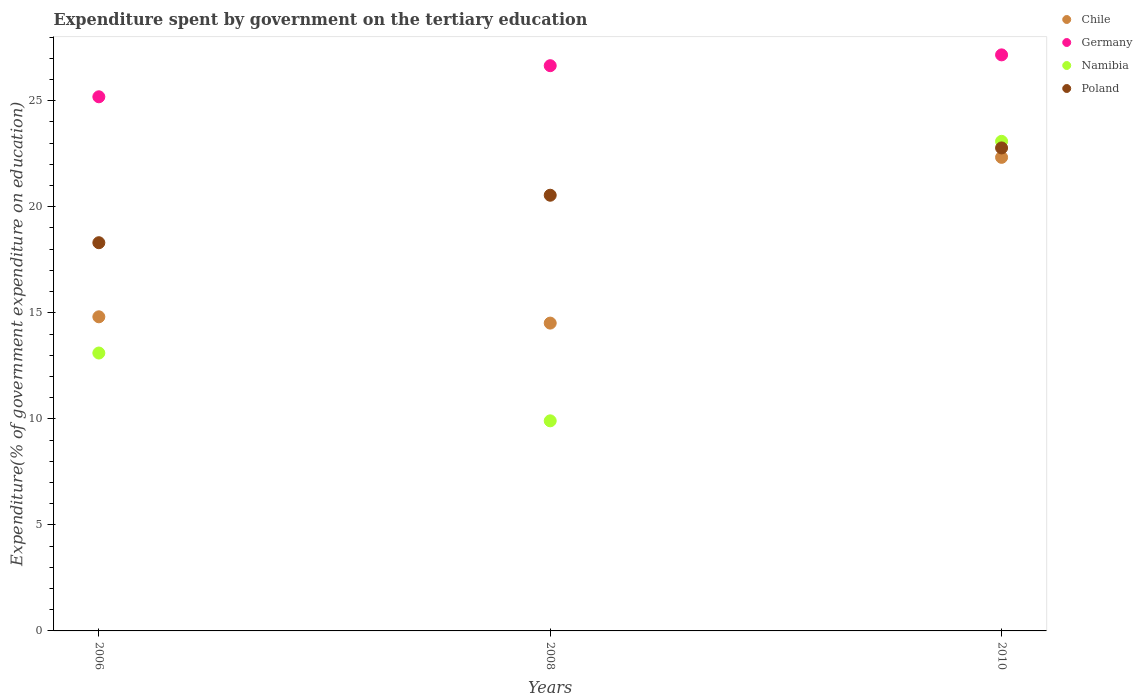Is the number of dotlines equal to the number of legend labels?
Keep it short and to the point. Yes. What is the expenditure spent by government on the tertiary education in Namibia in 2008?
Make the answer very short. 9.91. Across all years, what is the maximum expenditure spent by government on the tertiary education in Namibia?
Ensure brevity in your answer.  23.09. Across all years, what is the minimum expenditure spent by government on the tertiary education in Poland?
Provide a short and direct response. 18.31. In which year was the expenditure spent by government on the tertiary education in Germany minimum?
Make the answer very short. 2006. What is the total expenditure spent by government on the tertiary education in Poland in the graph?
Make the answer very short. 61.62. What is the difference between the expenditure spent by government on the tertiary education in Poland in 2006 and that in 2008?
Offer a very short reply. -2.24. What is the difference between the expenditure spent by government on the tertiary education in Chile in 2006 and the expenditure spent by government on the tertiary education in Germany in 2010?
Provide a short and direct response. -12.35. What is the average expenditure spent by government on the tertiary education in Poland per year?
Ensure brevity in your answer.  20.54. In the year 2008, what is the difference between the expenditure spent by government on the tertiary education in Namibia and expenditure spent by government on the tertiary education in Poland?
Offer a terse response. -10.64. What is the ratio of the expenditure spent by government on the tertiary education in Germany in 2006 to that in 2010?
Make the answer very short. 0.93. Is the expenditure spent by government on the tertiary education in Chile in 2006 less than that in 2010?
Provide a succinct answer. Yes. What is the difference between the highest and the second highest expenditure spent by government on the tertiary education in Germany?
Keep it short and to the point. 0.51. What is the difference between the highest and the lowest expenditure spent by government on the tertiary education in Germany?
Make the answer very short. 1.98. Is it the case that in every year, the sum of the expenditure spent by government on the tertiary education in Poland and expenditure spent by government on the tertiary education in Chile  is greater than the expenditure spent by government on the tertiary education in Namibia?
Keep it short and to the point. Yes. Does the expenditure spent by government on the tertiary education in Germany monotonically increase over the years?
Offer a terse response. Yes. Is the expenditure spent by government on the tertiary education in Namibia strictly greater than the expenditure spent by government on the tertiary education in Chile over the years?
Offer a very short reply. No. How many years are there in the graph?
Offer a terse response. 3. Are the values on the major ticks of Y-axis written in scientific E-notation?
Give a very brief answer. No. Does the graph contain any zero values?
Provide a short and direct response. No. Does the graph contain grids?
Provide a succinct answer. No. Where does the legend appear in the graph?
Give a very brief answer. Top right. How many legend labels are there?
Ensure brevity in your answer.  4. What is the title of the graph?
Ensure brevity in your answer.  Expenditure spent by government on the tertiary education. What is the label or title of the X-axis?
Provide a short and direct response. Years. What is the label or title of the Y-axis?
Provide a short and direct response. Expenditure(% of government expenditure on education). What is the Expenditure(% of government expenditure on education) in Chile in 2006?
Keep it short and to the point. 14.81. What is the Expenditure(% of government expenditure on education) of Germany in 2006?
Give a very brief answer. 25.19. What is the Expenditure(% of government expenditure on education) of Namibia in 2006?
Give a very brief answer. 13.1. What is the Expenditure(% of government expenditure on education) in Poland in 2006?
Keep it short and to the point. 18.31. What is the Expenditure(% of government expenditure on education) of Chile in 2008?
Ensure brevity in your answer.  14.51. What is the Expenditure(% of government expenditure on education) in Germany in 2008?
Offer a terse response. 26.65. What is the Expenditure(% of government expenditure on education) of Namibia in 2008?
Ensure brevity in your answer.  9.91. What is the Expenditure(% of government expenditure on education) in Poland in 2008?
Your response must be concise. 20.54. What is the Expenditure(% of government expenditure on education) in Chile in 2010?
Provide a succinct answer. 22.33. What is the Expenditure(% of government expenditure on education) of Germany in 2010?
Offer a very short reply. 27.16. What is the Expenditure(% of government expenditure on education) in Namibia in 2010?
Offer a terse response. 23.09. What is the Expenditure(% of government expenditure on education) in Poland in 2010?
Keep it short and to the point. 22.77. Across all years, what is the maximum Expenditure(% of government expenditure on education) of Chile?
Provide a short and direct response. 22.33. Across all years, what is the maximum Expenditure(% of government expenditure on education) of Germany?
Provide a short and direct response. 27.16. Across all years, what is the maximum Expenditure(% of government expenditure on education) in Namibia?
Your response must be concise. 23.09. Across all years, what is the maximum Expenditure(% of government expenditure on education) in Poland?
Make the answer very short. 22.77. Across all years, what is the minimum Expenditure(% of government expenditure on education) in Chile?
Give a very brief answer. 14.51. Across all years, what is the minimum Expenditure(% of government expenditure on education) of Germany?
Provide a succinct answer. 25.19. Across all years, what is the minimum Expenditure(% of government expenditure on education) in Namibia?
Your answer should be compact. 9.91. Across all years, what is the minimum Expenditure(% of government expenditure on education) in Poland?
Offer a very short reply. 18.31. What is the total Expenditure(% of government expenditure on education) of Chile in the graph?
Offer a very short reply. 51.66. What is the total Expenditure(% of government expenditure on education) of Germany in the graph?
Ensure brevity in your answer.  79. What is the total Expenditure(% of government expenditure on education) in Namibia in the graph?
Offer a terse response. 46.1. What is the total Expenditure(% of government expenditure on education) in Poland in the graph?
Your answer should be very brief. 61.62. What is the difference between the Expenditure(% of government expenditure on education) of Chile in 2006 and that in 2008?
Your response must be concise. 0.3. What is the difference between the Expenditure(% of government expenditure on education) of Germany in 2006 and that in 2008?
Ensure brevity in your answer.  -1.47. What is the difference between the Expenditure(% of government expenditure on education) in Namibia in 2006 and that in 2008?
Ensure brevity in your answer.  3.2. What is the difference between the Expenditure(% of government expenditure on education) of Poland in 2006 and that in 2008?
Offer a very short reply. -2.24. What is the difference between the Expenditure(% of government expenditure on education) in Chile in 2006 and that in 2010?
Offer a very short reply. -7.52. What is the difference between the Expenditure(% of government expenditure on education) in Germany in 2006 and that in 2010?
Keep it short and to the point. -1.98. What is the difference between the Expenditure(% of government expenditure on education) in Namibia in 2006 and that in 2010?
Provide a succinct answer. -9.98. What is the difference between the Expenditure(% of government expenditure on education) of Poland in 2006 and that in 2010?
Give a very brief answer. -4.47. What is the difference between the Expenditure(% of government expenditure on education) in Chile in 2008 and that in 2010?
Offer a very short reply. -7.82. What is the difference between the Expenditure(% of government expenditure on education) of Germany in 2008 and that in 2010?
Give a very brief answer. -0.51. What is the difference between the Expenditure(% of government expenditure on education) of Namibia in 2008 and that in 2010?
Make the answer very short. -13.18. What is the difference between the Expenditure(% of government expenditure on education) in Poland in 2008 and that in 2010?
Offer a very short reply. -2.23. What is the difference between the Expenditure(% of government expenditure on education) of Chile in 2006 and the Expenditure(% of government expenditure on education) of Germany in 2008?
Offer a terse response. -11.84. What is the difference between the Expenditure(% of government expenditure on education) of Chile in 2006 and the Expenditure(% of government expenditure on education) of Namibia in 2008?
Keep it short and to the point. 4.91. What is the difference between the Expenditure(% of government expenditure on education) of Chile in 2006 and the Expenditure(% of government expenditure on education) of Poland in 2008?
Ensure brevity in your answer.  -5.73. What is the difference between the Expenditure(% of government expenditure on education) in Germany in 2006 and the Expenditure(% of government expenditure on education) in Namibia in 2008?
Give a very brief answer. 15.28. What is the difference between the Expenditure(% of government expenditure on education) of Germany in 2006 and the Expenditure(% of government expenditure on education) of Poland in 2008?
Ensure brevity in your answer.  4.64. What is the difference between the Expenditure(% of government expenditure on education) of Namibia in 2006 and the Expenditure(% of government expenditure on education) of Poland in 2008?
Give a very brief answer. -7.44. What is the difference between the Expenditure(% of government expenditure on education) of Chile in 2006 and the Expenditure(% of government expenditure on education) of Germany in 2010?
Make the answer very short. -12.35. What is the difference between the Expenditure(% of government expenditure on education) of Chile in 2006 and the Expenditure(% of government expenditure on education) of Namibia in 2010?
Offer a terse response. -8.27. What is the difference between the Expenditure(% of government expenditure on education) in Chile in 2006 and the Expenditure(% of government expenditure on education) in Poland in 2010?
Your response must be concise. -7.96. What is the difference between the Expenditure(% of government expenditure on education) in Germany in 2006 and the Expenditure(% of government expenditure on education) in Namibia in 2010?
Keep it short and to the point. 2.1. What is the difference between the Expenditure(% of government expenditure on education) of Germany in 2006 and the Expenditure(% of government expenditure on education) of Poland in 2010?
Provide a succinct answer. 2.41. What is the difference between the Expenditure(% of government expenditure on education) in Namibia in 2006 and the Expenditure(% of government expenditure on education) in Poland in 2010?
Make the answer very short. -9.67. What is the difference between the Expenditure(% of government expenditure on education) in Chile in 2008 and the Expenditure(% of government expenditure on education) in Germany in 2010?
Your response must be concise. -12.65. What is the difference between the Expenditure(% of government expenditure on education) in Chile in 2008 and the Expenditure(% of government expenditure on education) in Namibia in 2010?
Your answer should be very brief. -8.57. What is the difference between the Expenditure(% of government expenditure on education) of Chile in 2008 and the Expenditure(% of government expenditure on education) of Poland in 2010?
Offer a very short reply. -8.26. What is the difference between the Expenditure(% of government expenditure on education) in Germany in 2008 and the Expenditure(% of government expenditure on education) in Namibia in 2010?
Provide a short and direct response. 3.57. What is the difference between the Expenditure(% of government expenditure on education) in Germany in 2008 and the Expenditure(% of government expenditure on education) in Poland in 2010?
Your response must be concise. 3.88. What is the difference between the Expenditure(% of government expenditure on education) of Namibia in 2008 and the Expenditure(% of government expenditure on education) of Poland in 2010?
Offer a terse response. -12.87. What is the average Expenditure(% of government expenditure on education) of Chile per year?
Keep it short and to the point. 17.22. What is the average Expenditure(% of government expenditure on education) in Germany per year?
Keep it short and to the point. 26.33. What is the average Expenditure(% of government expenditure on education) of Namibia per year?
Provide a succinct answer. 15.37. What is the average Expenditure(% of government expenditure on education) in Poland per year?
Your answer should be very brief. 20.54. In the year 2006, what is the difference between the Expenditure(% of government expenditure on education) in Chile and Expenditure(% of government expenditure on education) in Germany?
Your response must be concise. -10.37. In the year 2006, what is the difference between the Expenditure(% of government expenditure on education) of Chile and Expenditure(% of government expenditure on education) of Namibia?
Provide a succinct answer. 1.71. In the year 2006, what is the difference between the Expenditure(% of government expenditure on education) in Chile and Expenditure(% of government expenditure on education) in Poland?
Your answer should be compact. -3.49. In the year 2006, what is the difference between the Expenditure(% of government expenditure on education) in Germany and Expenditure(% of government expenditure on education) in Namibia?
Your response must be concise. 12.08. In the year 2006, what is the difference between the Expenditure(% of government expenditure on education) in Germany and Expenditure(% of government expenditure on education) in Poland?
Ensure brevity in your answer.  6.88. In the year 2006, what is the difference between the Expenditure(% of government expenditure on education) of Namibia and Expenditure(% of government expenditure on education) of Poland?
Give a very brief answer. -5.2. In the year 2008, what is the difference between the Expenditure(% of government expenditure on education) in Chile and Expenditure(% of government expenditure on education) in Germany?
Keep it short and to the point. -12.14. In the year 2008, what is the difference between the Expenditure(% of government expenditure on education) of Chile and Expenditure(% of government expenditure on education) of Namibia?
Ensure brevity in your answer.  4.61. In the year 2008, what is the difference between the Expenditure(% of government expenditure on education) in Chile and Expenditure(% of government expenditure on education) in Poland?
Keep it short and to the point. -6.03. In the year 2008, what is the difference between the Expenditure(% of government expenditure on education) of Germany and Expenditure(% of government expenditure on education) of Namibia?
Provide a succinct answer. 16.75. In the year 2008, what is the difference between the Expenditure(% of government expenditure on education) of Germany and Expenditure(% of government expenditure on education) of Poland?
Offer a very short reply. 6.11. In the year 2008, what is the difference between the Expenditure(% of government expenditure on education) in Namibia and Expenditure(% of government expenditure on education) in Poland?
Keep it short and to the point. -10.64. In the year 2010, what is the difference between the Expenditure(% of government expenditure on education) of Chile and Expenditure(% of government expenditure on education) of Germany?
Give a very brief answer. -4.83. In the year 2010, what is the difference between the Expenditure(% of government expenditure on education) of Chile and Expenditure(% of government expenditure on education) of Namibia?
Give a very brief answer. -0.76. In the year 2010, what is the difference between the Expenditure(% of government expenditure on education) of Chile and Expenditure(% of government expenditure on education) of Poland?
Give a very brief answer. -0.44. In the year 2010, what is the difference between the Expenditure(% of government expenditure on education) of Germany and Expenditure(% of government expenditure on education) of Namibia?
Ensure brevity in your answer.  4.08. In the year 2010, what is the difference between the Expenditure(% of government expenditure on education) of Germany and Expenditure(% of government expenditure on education) of Poland?
Offer a very short reply. 4.39. In the year 2010, what is the difference between the Expenditure(% of government expenditure on education) of Namibia and Expenditure(% of government expenditure on education) of Poland?
Offer a very short reply. 0.31. What is the ratio of the Expenditure(% of government expenditure on education) of Chile in 2006 to that in 2008?
Provide a short and direct response. 1.02. What is the ratio of the Expenditure(% of government expenditure on education) of Germany in 2006 to that in 2008?
Offer a very short reply. 0.94. What is the ratio of the Expenditure(% of government expenditure on education) in Namibia in 2006 to that in 2008?
Your answer should be very brief. 1.32. What is the ratio of the Expenditure(% of government expenditure on education) in Poland in 2006 to that in 2008?
Your response must be concise. 0.89. What is the ratio of the Expenditure(% of government expenditure on education) of Chile in 2006 to that in 2010?
Your response must be concise. 0.66. What is the ratio of the Expenditure(% of government expenditure on education) in Germany in 2006 to that in 2010?
Your answer should be very brief. 0.93. What is the ratio of the Expenditure(% of government expenditure on education) of Namibia in 2006 to that in 2010?
Ensure brevity in your answer.  0.57. What is the ratio of the Expenditure(% of government expenditure on education) in Poland in 2006 to that in 2010?
Your answer should be compact. 0.8. What is the ratio of the Expenditure(% of government expenditure on education) in Chile in 2008 to that in 2010?
Your answer should be compact. 0.65. What is the ratio of the Expenditure(% of government expenditure on education) in Germany in 2008 to that in 2010?
Provide a short and direct response. 0.98. What is the ratio of the Expenditure(% of government expenditure on education) in Namibia in 2008 to that in 2010?
Your answer should be compact. 0.43. What is the ratio of the Expenditure(% of government expenditure on education) of Poland in 2008 to that in 2010?
Make the answer very short. 0.9. What is the difference between the highest and the second highest Expenditure(% of government expenditure on education) in Chile?
Ensure brevity in your answer.  7.52. What is the difference between the highest and the second highest Expenditure(% of government expenditure on education) in Germany?
Provide a succinct answer. 0.51. What is the difference between the highest and the second highest Expenditure(% of government expenditure on education) of Namibia?
Your response must be concise. 9.98. What is the difference between the highest and the second highest Expenditure(% of government expenditure on education) of Poland?
Give a very brief answer. 2.23. What is the difference between the highest and the lowest Expenditure(% of government expenditure on education) in Chile?
Give a very brief answer. 7.82. What is the difference between the highest and the lowest Expenditure(% of government expenditure on education) in Germany?
Provide a succinct answer. 1.98. What is the difference between the highest and the lowest Expenditure(% of government expenditure on education) in Namibia?
Offer a terse response. 13.18. What is the difference between the highest and the lowest Expenditure(% of government expenditure on education) of Poland?
Make the answer very short. 4.47. 